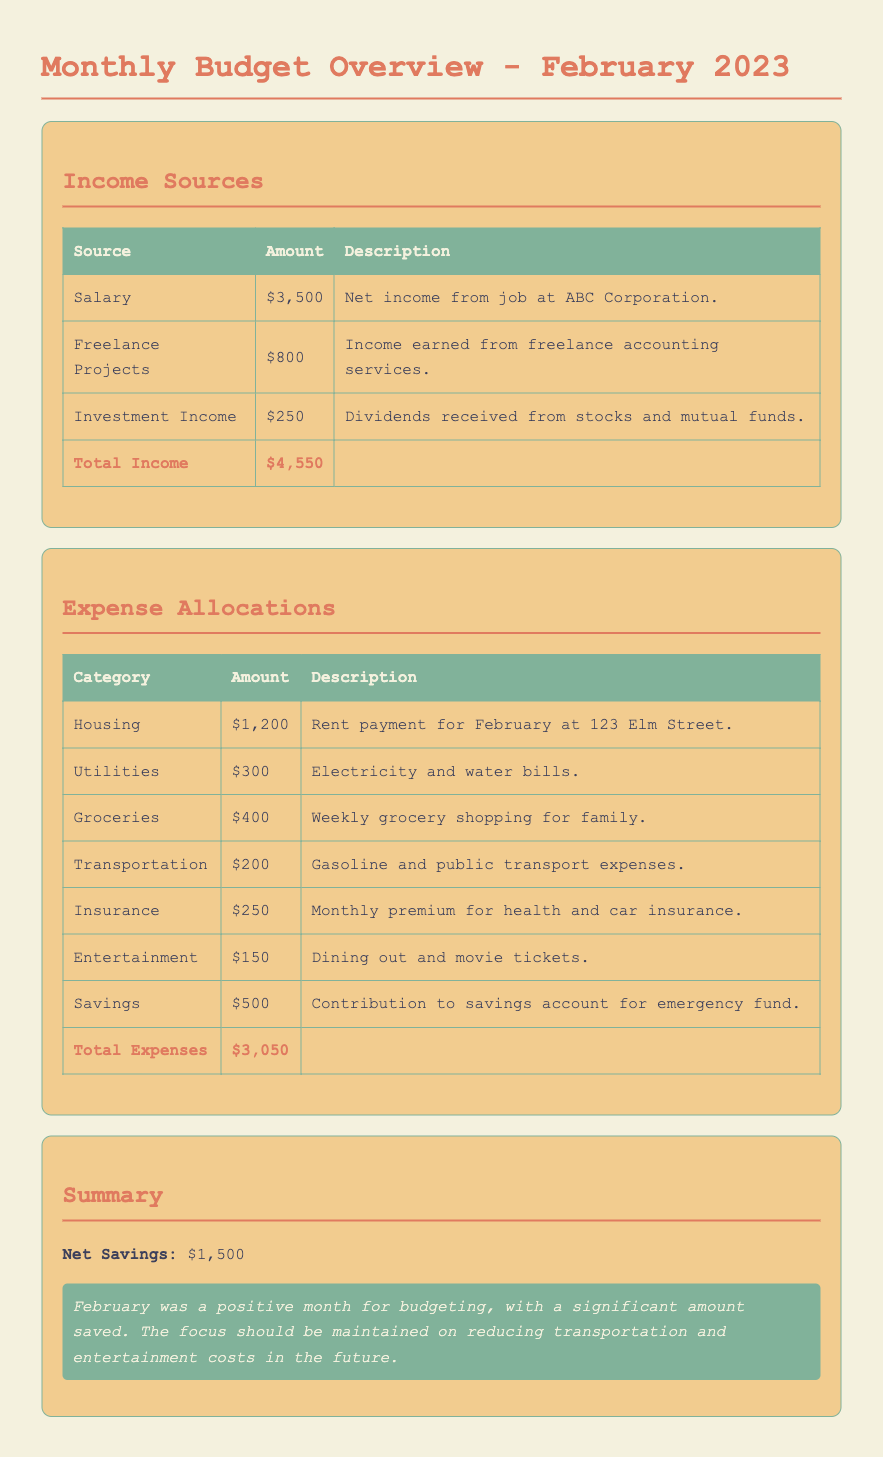What is the total income for February 2023? The total income is calculated by summing up all the income sources listed, which are $3,500 from salary, $800 from freelance projects, and $250 from investment income.
Answer: $4,550 What is the amount spent on groceries? The document indicates the amount allocated for groceries under the expense allocations section, which is provided as $400.
Answer: $400 How much was allocated for transportation? The transportation expense is listed in the table under expense allocations, showing an amount of $200.
Answer: $200 What is the net savings for February 2023? The net savings is determined by subtracting total expenses from total income, which is $4,550 (income) - $3,050 (expenses) = $1,500.
Answer: $1,500 What is the total amount spent on utilities? The amount for utilities is clearly stated in the expense table, which amounts to $300.
Answer: $300 What was the highest expense category? By comparing the amounts in the expense allocations, housing is found to be the highest expense category, costing $1,200.
Answer: Housing What is the total amount for savings? The savings category in the expenses indicates a specific amount allocated, which is $500 for the month.
Answer: $500 What is the description of the income earned from freelance projects? The description for freelance projects provides context for the income source, stating it is the income earned from freelance accounting services.
Answer: Income earned from freelance accounting services What is the total for entertainment expenses? The entertainment expenses are precisely listed, showing an amount of $150 in the expense allocations.
Answer: $150 